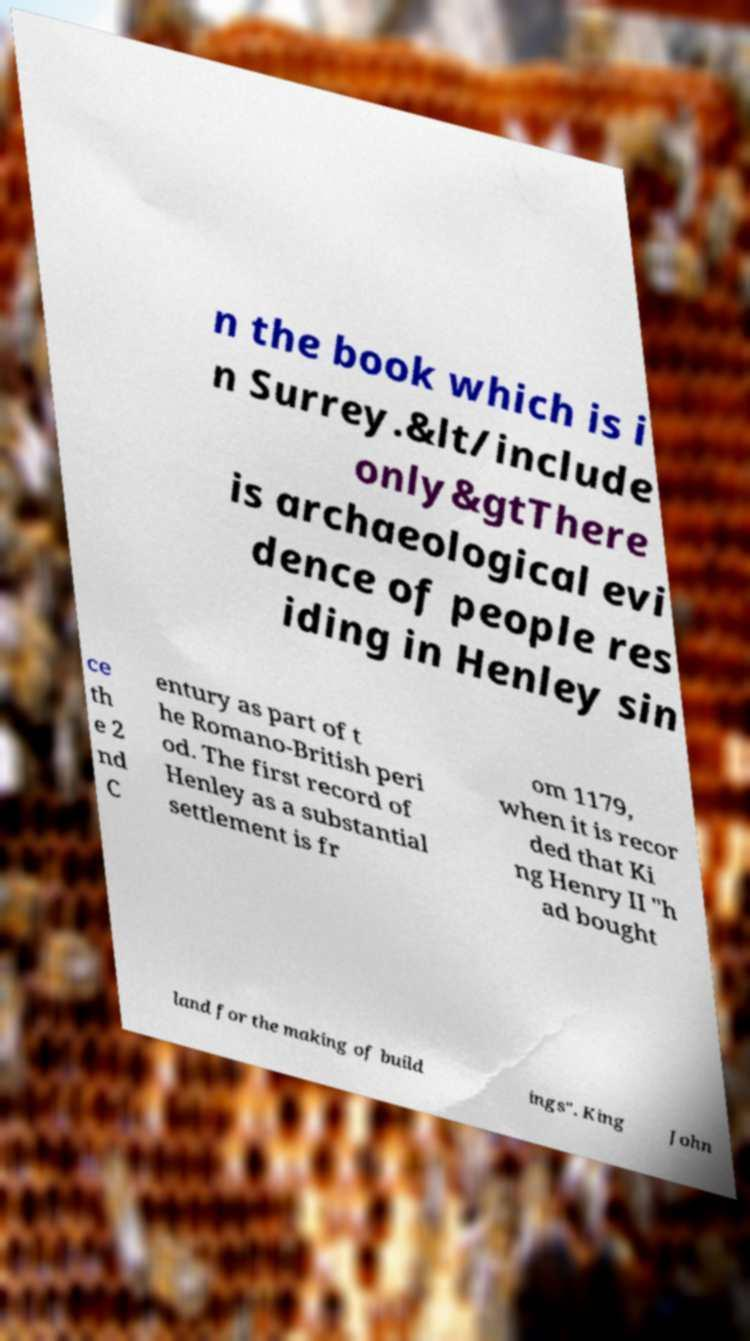Could you assist in decoding the text presented in this image and type it out clearly? n the book which is i n Surrey.&lt/include only&gtThere is archaeological evi dence of people res iding in Henley sin ce th e 2 nd C entury as part of t he Romano-British peri od. The first record of Henley as a substantial settlement is fr om 1179, when it is recor ded that Ki ng Henry II "h ad bought land for the making of build ings". King John 